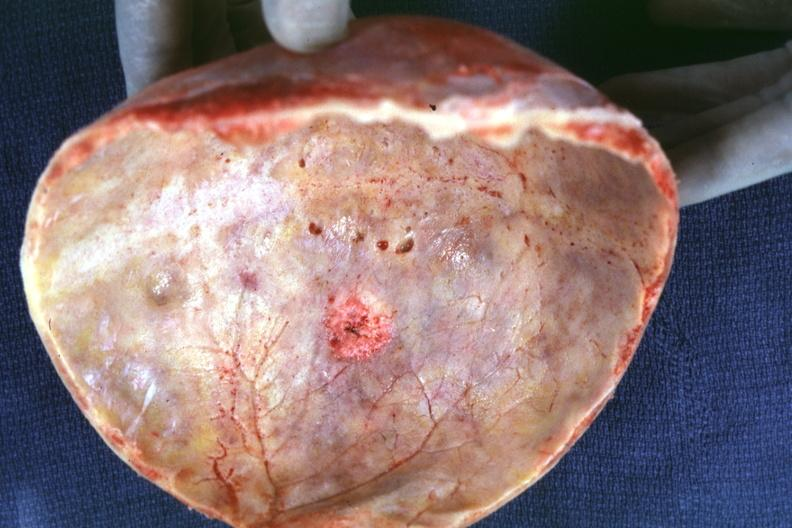what is present?
Answer the question using a single word or phrase. Metastatic carcinoma 